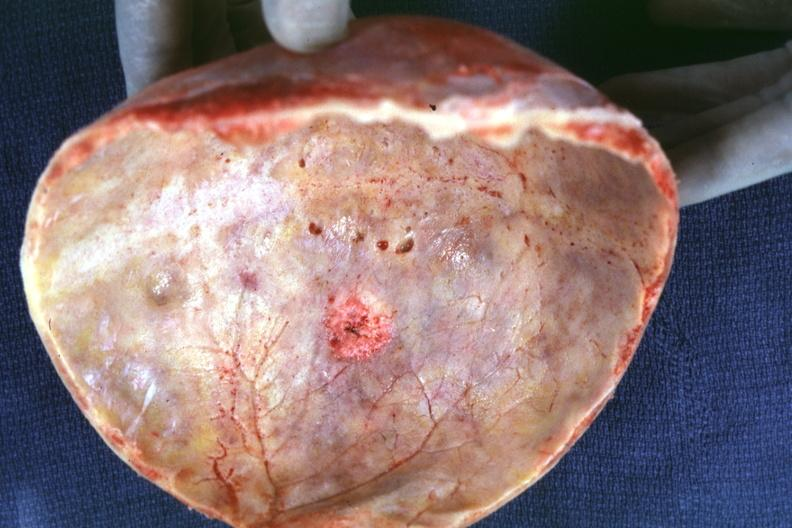what is present?
Answer the question using a single word or phrase. Metastatic carcinoma 